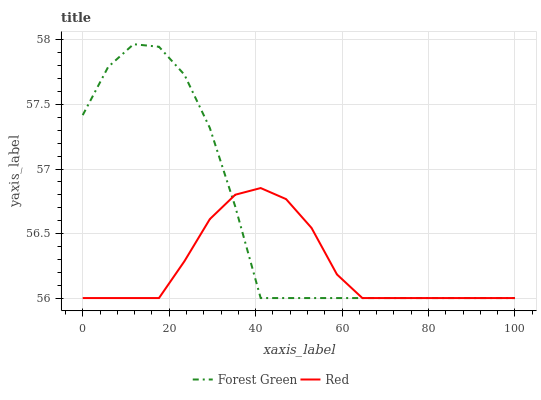Does Red have the minimum area under the curve?
Answer yes or no. Yes. Does Forest Green have the maximum area under the curve?
Answer yes or no. Yes. Does Red have the maximum area under the curve?
Answer yes or no. No. Is Red the smoothest?
Answer yes or no. Yes. Is Forest Green the roughest?
Answer yes or no. Yes. Is Red the roughest?
Answer yes or no. No. Does Forest Green have the lowest value?
Answer yes or no. Yes. Does Forest Green have the highest value?
Answer yes or no. Yes. Does Red have the highest value?
Answer yes or no. No. Does Forest Green intersect Red?
Answer yes or no. Yes. Is Forest Green less than Red?
Answer yes or no. No. Is Forest Green greater than Red?
Answer yes or no. No. 